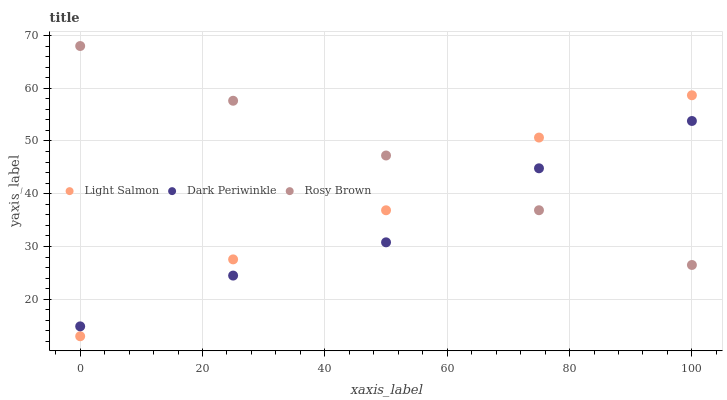Does Dark Periwinkle have the minimum area under the curve?
Answer yes or no. Yes. Does Rosy Brown have the maximum area under the curve?
Answer yes or no. Yes. Does Rosy Brown have the minimum area under the curve?
Answer yes or no. No. Does Dark Periwinkle have the maximum area under the curve?
Answer yes or no. No. Is Rosy Brown the smoothest?
Answer yes or no. Yes. Is Dark Periwinkle the roughest?
Answer yes or no. Yes. Is Dark Periwinkle the smoothest?
Answer yes or no. No. Is Rosy Brown the roughest?
Answer yes or no. No. Does Light Salmon have the lowest value?
Answer yes or no. Yes. Does Dark Periwinkle have the lowest value?
Answer yes or no. No. Does Rosy Brown have the highest value?
Answer yes or no. Yes. Does Dark Periwinkle have the highest value?
Answer yes or no. No. Does Dark Periwinkle intersect Rosy Brown?
Answer yes or no. Yes. Is Dark Periwinkle less than Rosy Brown?
Answer yes or no. No. Is Dark Periwinkle greater than Rosy Brown?
Answer yes or no. No. 